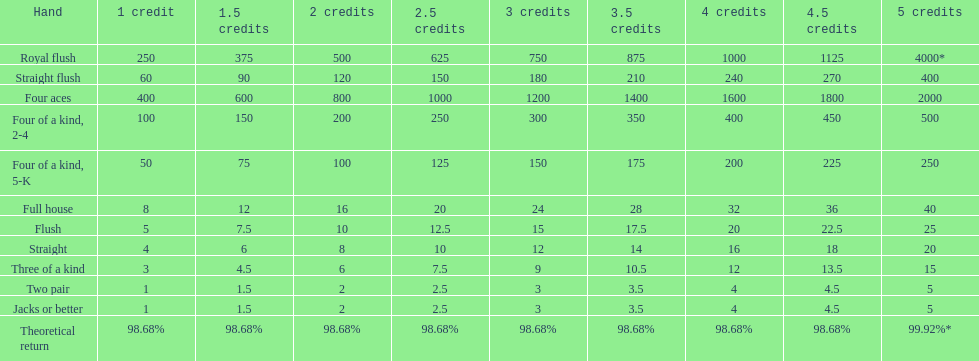For a straight flush win at two credits, how many straight wins at three credits would be equal in value? 10. 